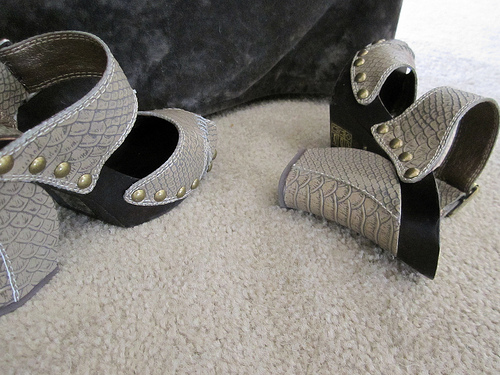<image>
Can you confirm if the shoe is in front of the right shoe? No. The shoe is not in front of the right shoe. The spatial positioning shows a different relationship between these objects. Is the shoe one to the left of the shoe two? Yes. From this viewpoint, the shoe one is positioned to the left side relative to the shoe two. 